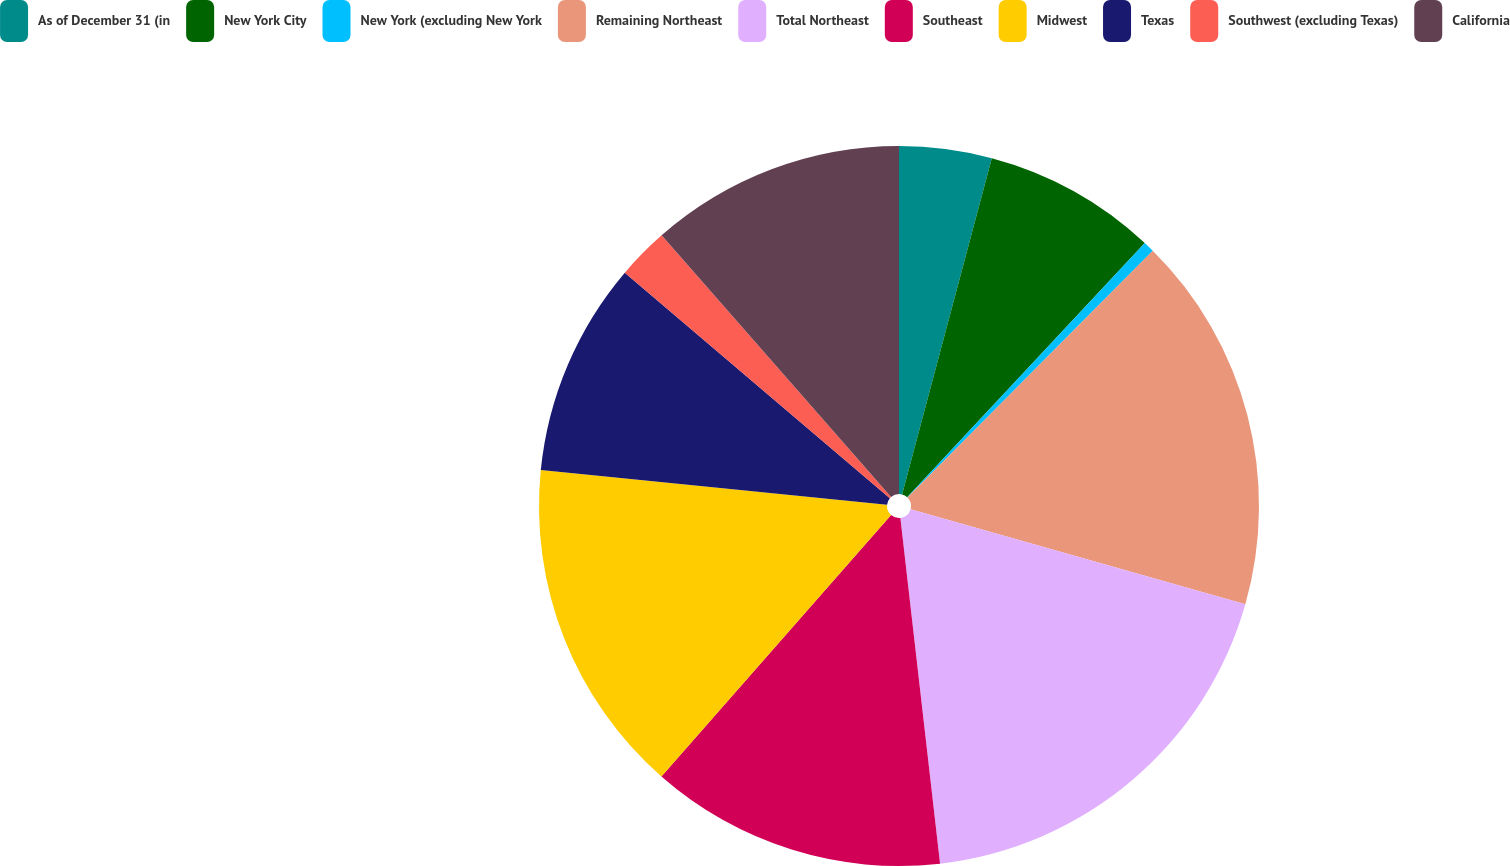Convert chart. <chart><loc_0><loc_0><loc_500><loc_500><pie_chart><fcel>As of December 31 (in<fcel>New York City<fcel>New York (excluding New York<fcel>Remaining Northeast<fcel>Total Northeast<fcel>Southeast<fcel>Midwest<fcel>Texas<fcel>Southwest (excluding Texas)<fcel>California<nl><fcel>4.15%<fcel>7.81%<fcel>0.49%<fcel>16.95%<fcel>18.78%<fcel>13.29%<fcel>15.12%<fcel>9.63%<fcel>2.32%<fcel>11.46%<nl></chart> 